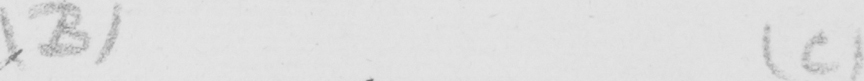Please transcribe the handwritten text in this image. ( B )   ( C ) 